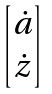Convert formula to latex. <formula><loc_0><loc_0><loc_500><loc_500>\begin{bmatrix} \dot { a } \\ \dot { z } \end{bmatrix}</formula> 